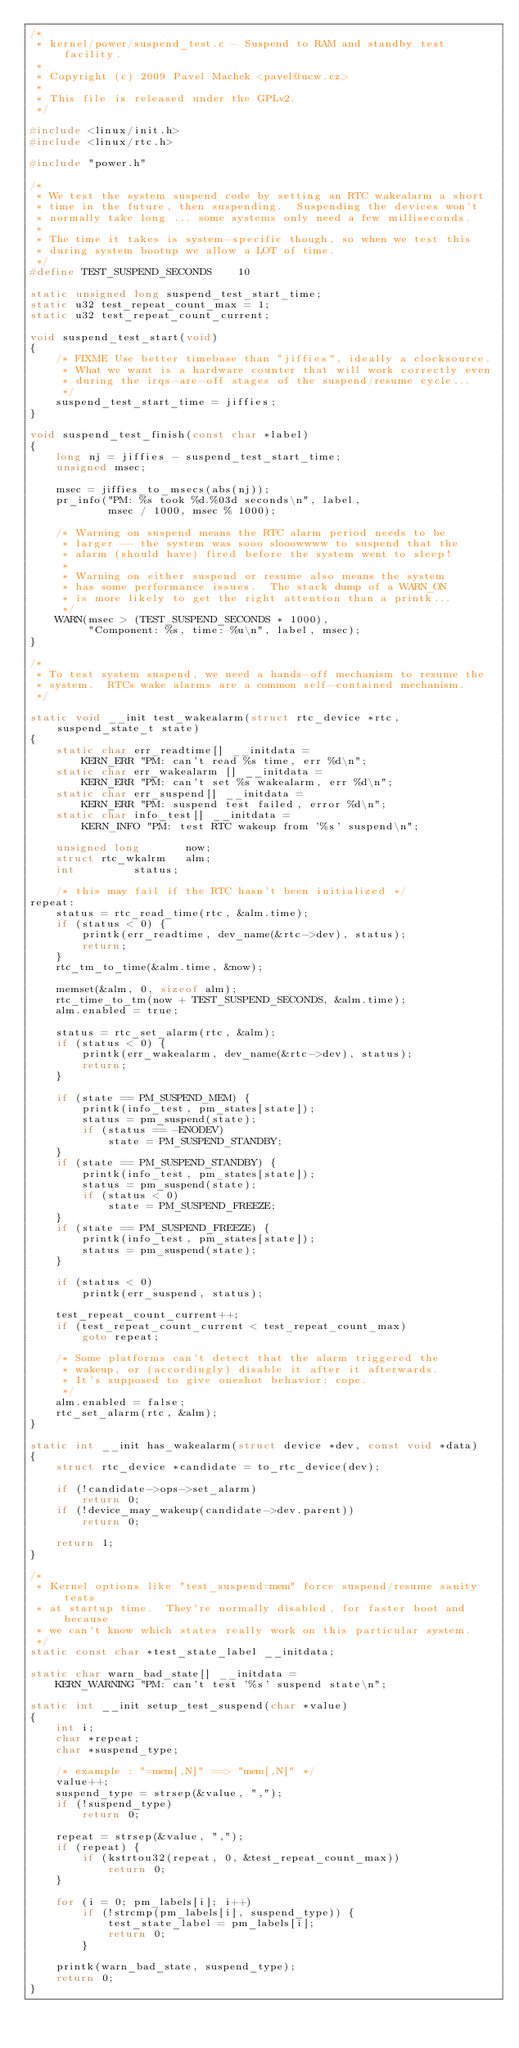<code> <loc_0><loc_0><loc_500><loc_500><_C_>/*
 * kernel/power/suspend_test.c - Suspend to RAM and standby test facility.
 *
 * Copyright (c) 2009 Pavel Machek <pavel@ucw.cz>
 *
 * This file is released under the GPLv2.
 */

#include <linux/init.h>
#include <linux/rtc.h>

#include "power.h"

/*
 * We test the system suspend code by setting an RTC wakealarm a short
 * time in the future, then suspending.  Suspending the devices won't
 * normally take long ... some systems only need a few milliseconds.
 *
 * The time it takes is system-specific though, so when we test this
 * during system bootup we allow a LOT of time.
 */
#define TEST_SUSPEND_SECONDS	10

static unsigned long suspend_test_start_time;
static u32 test_repeat_count_max = 1;
static u32 test_repeat_count_current;

void suspend_test_start(void)
{
	/* FIXME Use better timebase than "jiffies", ideally a clocksource.
	 * What we want is a hardware counter that will work correctly even
	 * during the irqs-are-off stages of the suspend/resume cycle...
	 */
	suspend_test_start_time = jiffies;
}

void suspend_test_finish(const char *label)
{
	long nj = jiffies - suspend_test_start_time;
	unsigned msec;

	msec = jiffies_to_msecs(abs(nj));
	pr_info("PM: %s took %d.%03d seconds\n", label,
			msec / 1000, msec % 1000);

	/* Warning on suspend means the RTC alarm period needs to be
	 * larger -- the system was sooo slooowwww to suspend that the
	 * alarm (should have) fired before the system went to sleep!
	 *
	 * Warning on either suspend or resume also means the system
	 * has some performance issues.  The stack dump of a WARN_ON
	 * is more likely to get the right attention than a printk...
	 */
	WARN(msec > (TEST_SUSPEND_SECONDS * 1000),
	     "Component: %s, time: %u\n", label, msec);
}

/*
 * To test system suspend, we need a hands-off mechanism to resume the
 * system.  RTCs wake alarms are a common self-contained mechanism.
 */

static void __init test_wakealarm(struct rtc_device *rtc, suspend_state_t state)
{
	static char err_readtime[] __initdata =
		KERN_ERR "PM: can't read %s time, err %d\n";
	static char err_wakealarm [] __initdata =
		KERN_ERR "PM: can't set %s wakealarm, err %d\n";
	static char err_suspend[] __initdata =
		KERN_ERR "PM: suspend test failed, error %d\n";
	static char info_test[] __initdata =
		KERN_INFO "PM: test RTC wakeup from '%s' suspend\n";

	unsigned long		now;
	struct rtc_wkalrm	alm;
	int			status;

	/* this may fail if the RTC hasn't been initialized */
repeat:
	status = rtc_read_time(rtc, &alm.time);
	if (status < 0) {
		printk(err_readtime, dev_name(&rtc->dev), status);
		return;
	}
	rtc_tm_to_time(&alm.time, &now);

	memset(&alm, 0, sizeof alm);
	rtc_time_to_tm(now + TEST_SUSPEND_SECONDS, &alm.time);
	alm.enabled = true;

	status = rtc_set_alarm(rtc, &alm);
	if (status < 0) {
		printk(err_wakealarm, dev_name(&rtc->dev), status);
		return;
	}

	if (state == PM_SUSPEND_MEM) {
		printk(info_test, pm_states[state]);
		status = pm_suspend(state);
		if (status == -ENODEV)
			state = PM_SUSPEND_STANDBY;
	}
	if (state == PM_SUSPEND_STANDBY) {
		printk(info_test, pm_states[state]);
		status = pm_suspend(state);
		if (status < 0)
			state = PM_SUSPEND_FREEZE;
	}
	if (state == PM_SUSPEND_FREEZE) {
		printk(info_test, pm_states[state]);
		status = pm_suspend(state);
	}

	if (status < 0)
		printk(err_suspend, status);

	test_repeat_count_current++;
	if (test_repeat_count_current < test_repeat_count_max)
		goto repeat;

	/* Some platforms can't detect that the alarm triggered the
	 * wakeup, or (accordingly) disable it after it afterwards.
	 * It's supposed to give oneshot behavior; cope.
	 */
	alm.enabled = false;
	rtc_set_alarm(rtc, &alm);
}

static int __init has_wakealarm(struct device *dev, const void *data)
{
	struct rtc_device *candidate = to_rtc_device(dev);

	if (!candidate->ops->set_alarm)
		return 0;
	if (!device_may_wakeup(candidate->dev.parent))
		return 0;

	return 1;
}

/*
 * Kernel options like "test_suspend=mem" force suspend/resume sanity tests
 * at startup time.  They're normally disabled, for faster boot and because
 * we can't know which states really work on this particular system.
 */
static const char *test_state_label __initdata;

static char warn_bad_state[] __initdata =
	KERN_WARNING "PM: can't test '%s' suspend state\n";

static int __init setup_test_suspend(char *value)
{
	int i;
	char *repeat;
	char *suspend_type;

	/* example : "=mem[,N]" ==> "mem[,N]" */
	value++;
	suspend_type = strsep(&value, ",");
	if (!suspend_type)
		return 0;

	repeat = strsep(&value, ",");
	if (repeat) {
		if (kstrtou32(repeat, 0, &test_repeat_count_max))
			return 0;
	}

	for (i = 0; pm_labels[i]; i++)
		if (!strcmp(pm_labels[i], suspend_type)) {
			test_state_label = pm_labels[i];
			return 0;
		}

	printk(warn_bad_state, suspend_type);
	return 0;
}</code> 